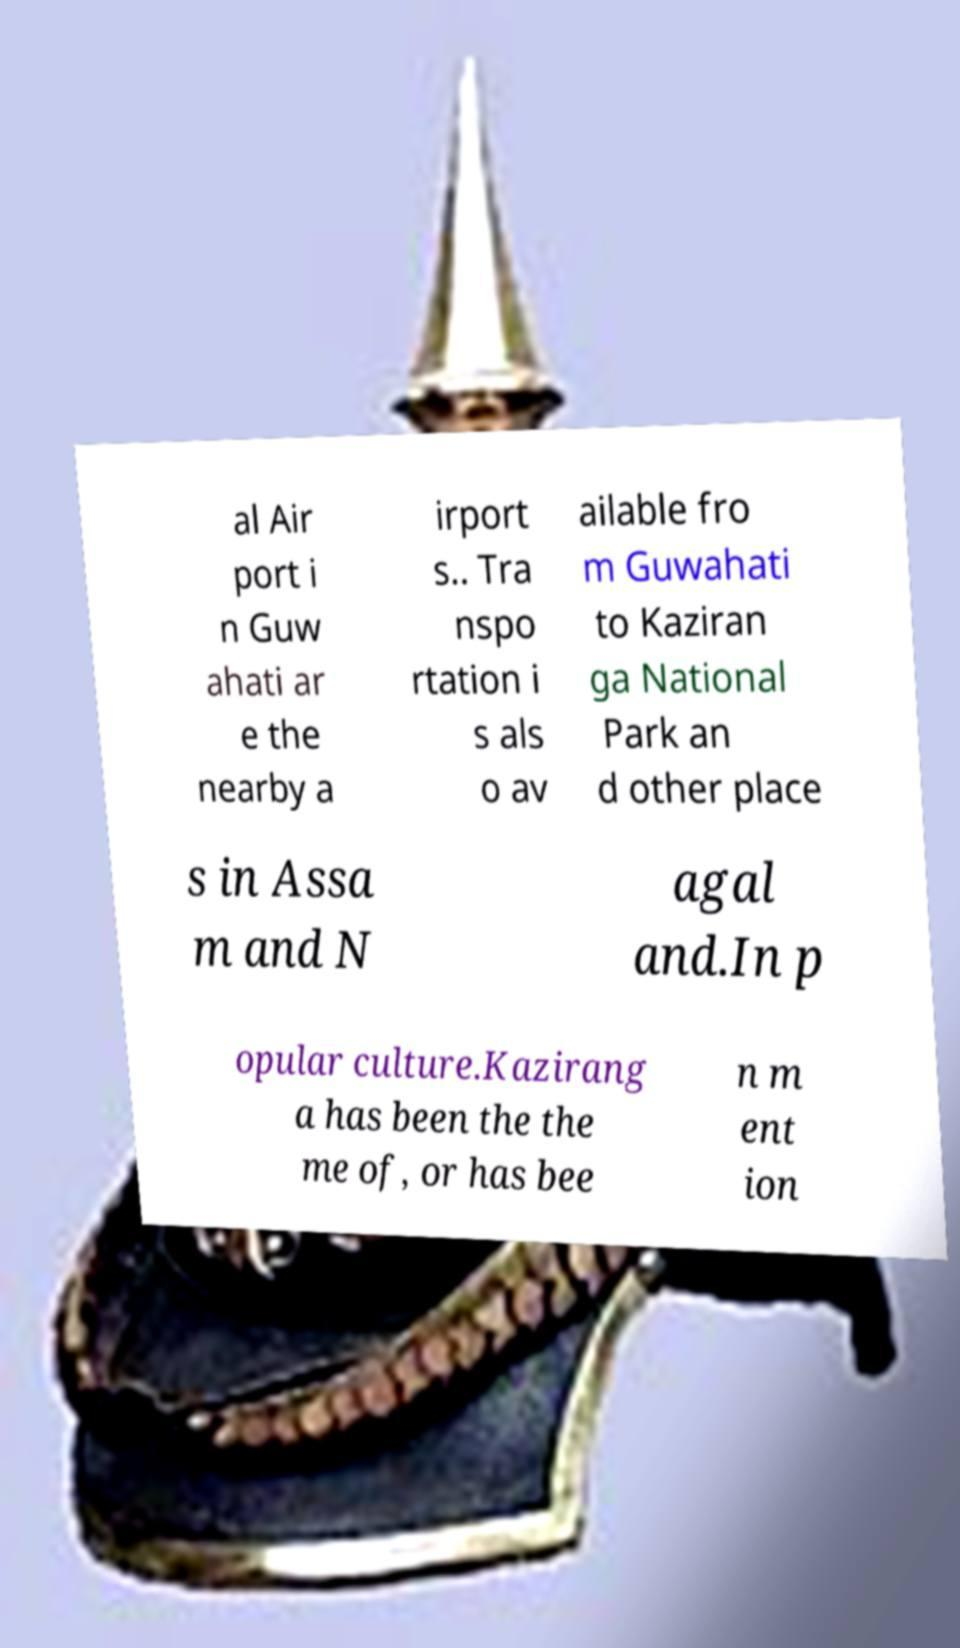There's text embedded in this image that I need extracted. Can you transcribe it verbatim? al Air port i n Guw ahati ar e the nearby a irport s.. Tra nspo rtation i s als o av ailable fro m Guwahati to Kaziran ga National Park an d other place s in Assa m and N agal and.In p opular culture.Kazirang a has been the the me of, or has bee n m ent ion 